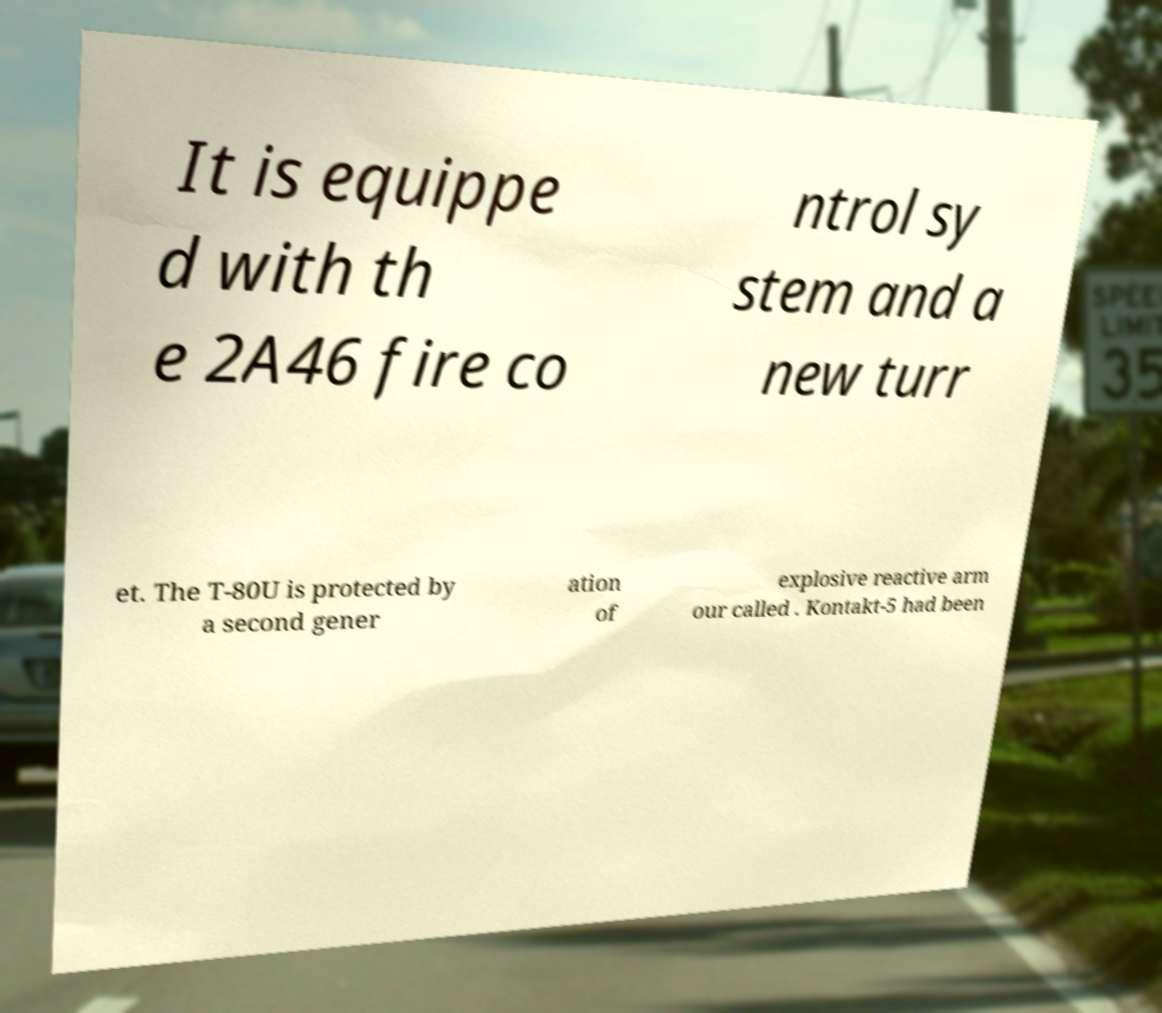Could you extract and type out the text from this image? It is equippe d with th e 2A46 fire co ntrol sy stem and a new turr et. The T-80U is protected by a second gener ation of explosive reactive arm our called . Kontakt-5 had been 